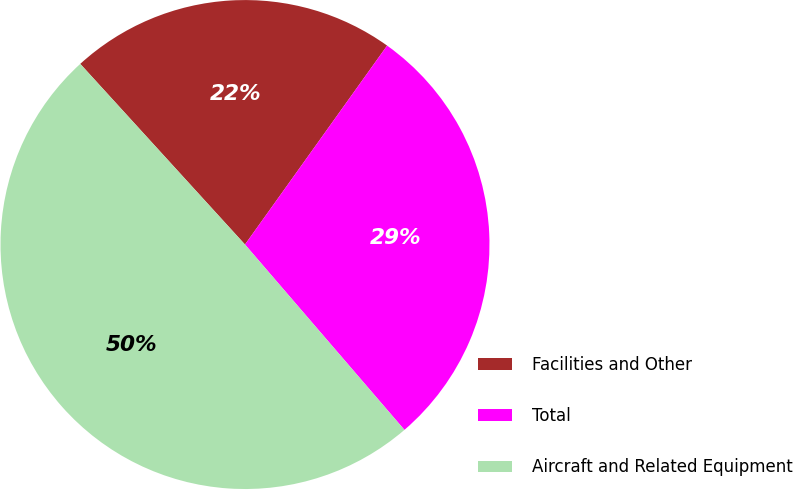<chart> <loc_0><loc_0><loc_500><loc_500><pie_chart><fcel>Facilities and Other<fcel>Total<fcel>Aircraft and Related Equipment<nl><fcel>21.64%<fcel>28.82%<fcel>49.54%<nl></chart> 